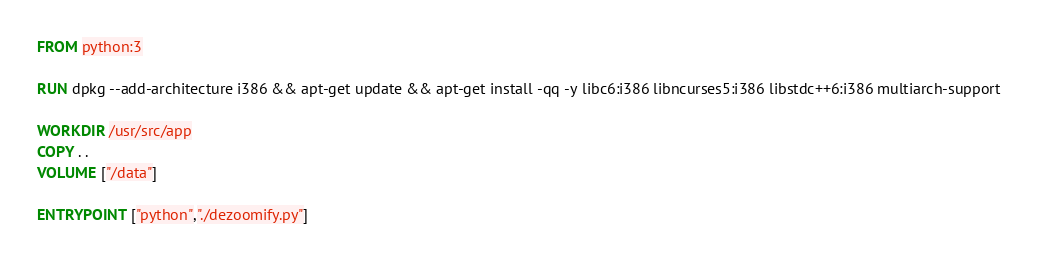<code> <loc_0><loc_0><loc_500><loc_500><_Dockerfile_>FROM python:3

RUN dpkg --add-architecture i386 && apt-get update && apt-get install -qq -y libc6:i386 libncurses5:i386 libstdc++6:i386 multiarch-support

WORKDIR /usr/src/app
COPY . .
VOLUME ["/data"]

ENTRYPOINT ["python","./dezoomify.py"]
</code> 